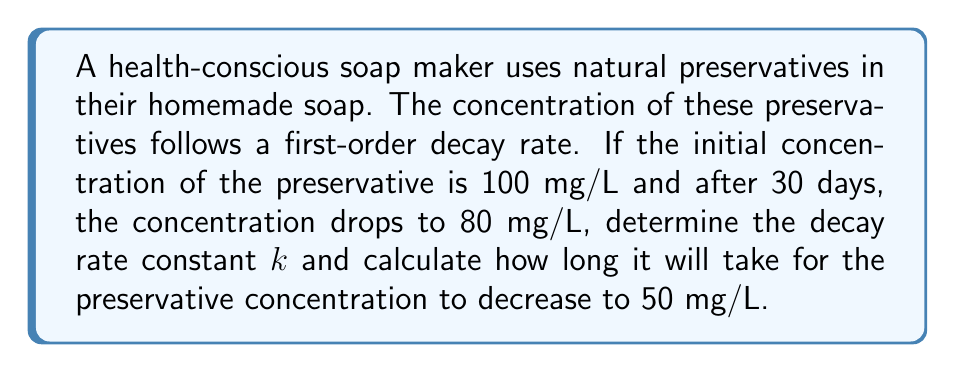Provide a solution to this math problem. To solve this problem, we'll use the first-order decay equation:

$$C(t) = C_0 e^{-kt}$$

Where:
$C(t)$ is the concentration at time $t$
$C_0$ is the initial concentration
$k$ is the decay rate constant
$t$ is time

1) First, let's find the decay rate constant $k$:

Given:
$C_0 = 100$ mg/L
$C(30) = 80$ mg/L
$t = 30$ days

Substituting into the equation:

$$80 = 100 e^{-k(30)}$$

Dividing both sides by 100:

$$0.8 = e^{-30k}$$

Taking the natural log of both sides:

$$\ln(0.8) = -30k$$

Solving for $k$:

$$k = -\frac{\ln(0.8)}{30} \approx 0.00744 \text{ day}^{-1}$$

2) Now, to find how long it takes for the concentration to reach 50 mg/L:

Using the same equation, but now with $k = 0.00744$ and $C(t) = 50$:

$$50 = 100 e^{-0.00744t}$$

Dividing both sides by 100:

$$0.5 = e^{-0.00744t}$$

Taking the natural log of both sides:

$$\ln(0.5) = -0.00744t$$

Solving for $t$:

$$t = -\frac{\ln(0.5)}{0.00744} \approx 93.15 \text{ days}$$
Answer: The decay rate constant $k$ is approximately $0.00744 \text{ day}^{-1}$, and it will take about 93 days for the preservative concentration to decrease to 50 mg/L. 